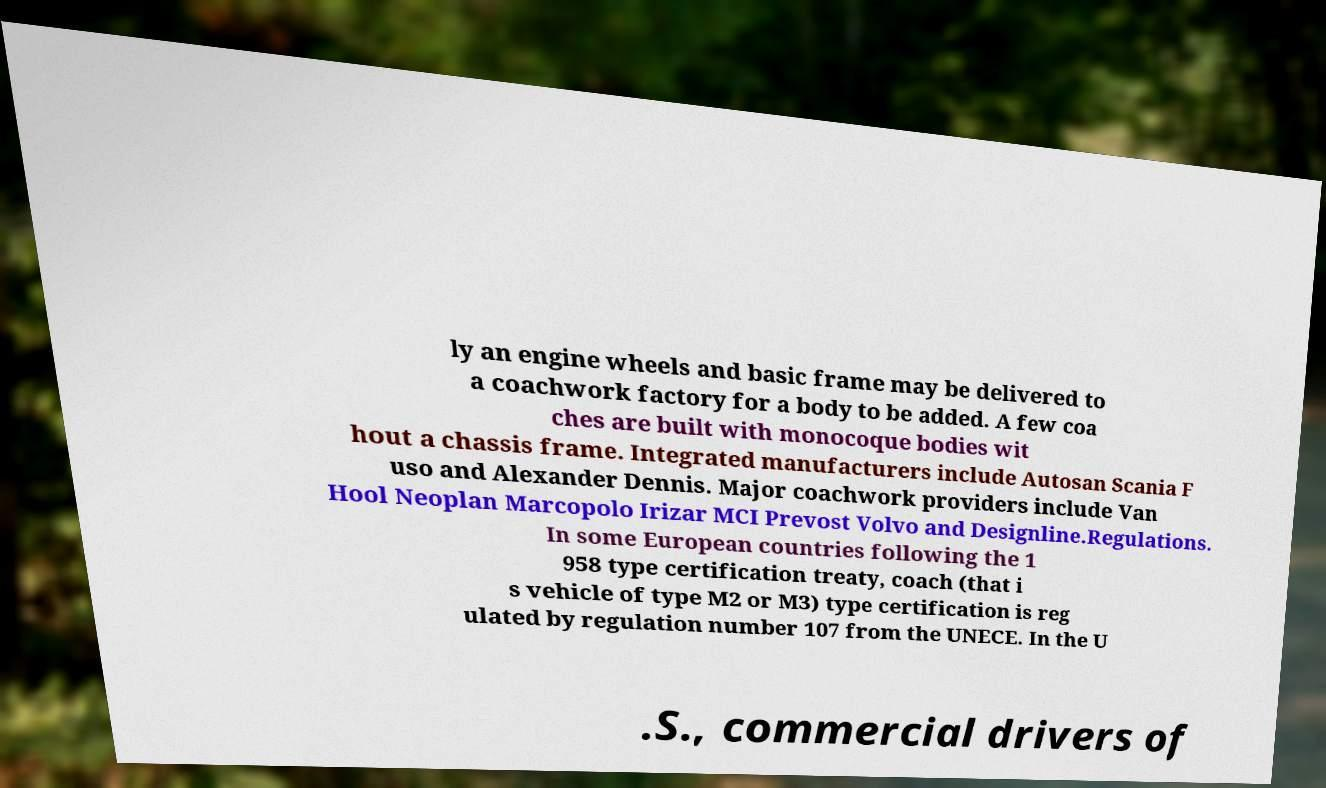Please read and relay the text visible in this image. What does it say? ly an engine wheels and basic frame may be delivered to a coachwork factory for a body to be added. A few coa ches are built with monocoque bodies wit hout a chassis frame. Integrated manufacturers include Autosan Scania F uso and Alexander Dennis. Major coachwork providers include Van Hool Neoplan Marcopolo Irizar MCI Prevost Volvo and Designline.Regulations. In some European countries following the 1 958 type certification treaty, coach (that i s vehicle of type M2 or M3) type certification is reg ulated by regulation number 107 from the UNECE. In the U .S., commercial drivers of 